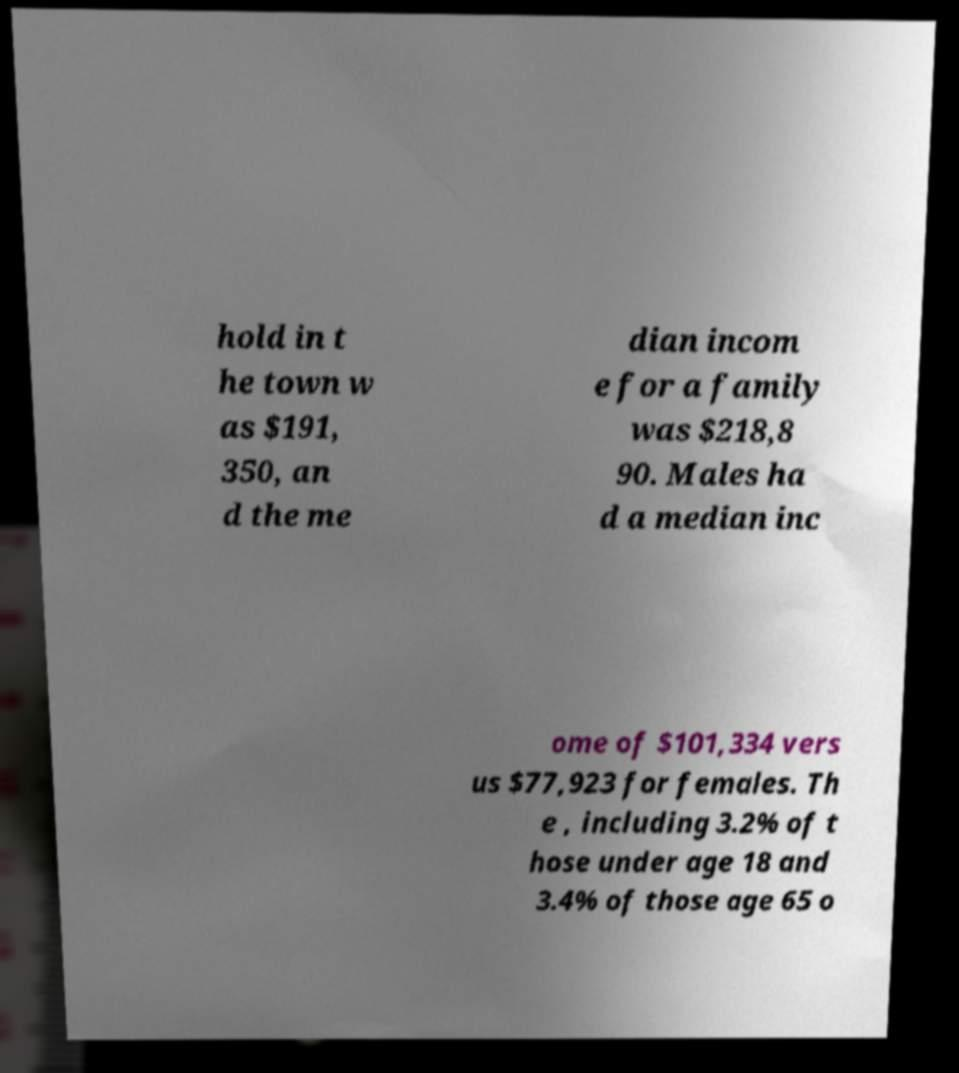Can you accurately transcribe the text from the provided image for me? hold in t he town w as $191, 350, an d the me dian incom e for a family was $218,8 90. Males ha d a median inc ome of $101,334 vers us $77,923 for females. Th e , including 3.2% of t hose under age 18 and 3.4% of those age 65 o 